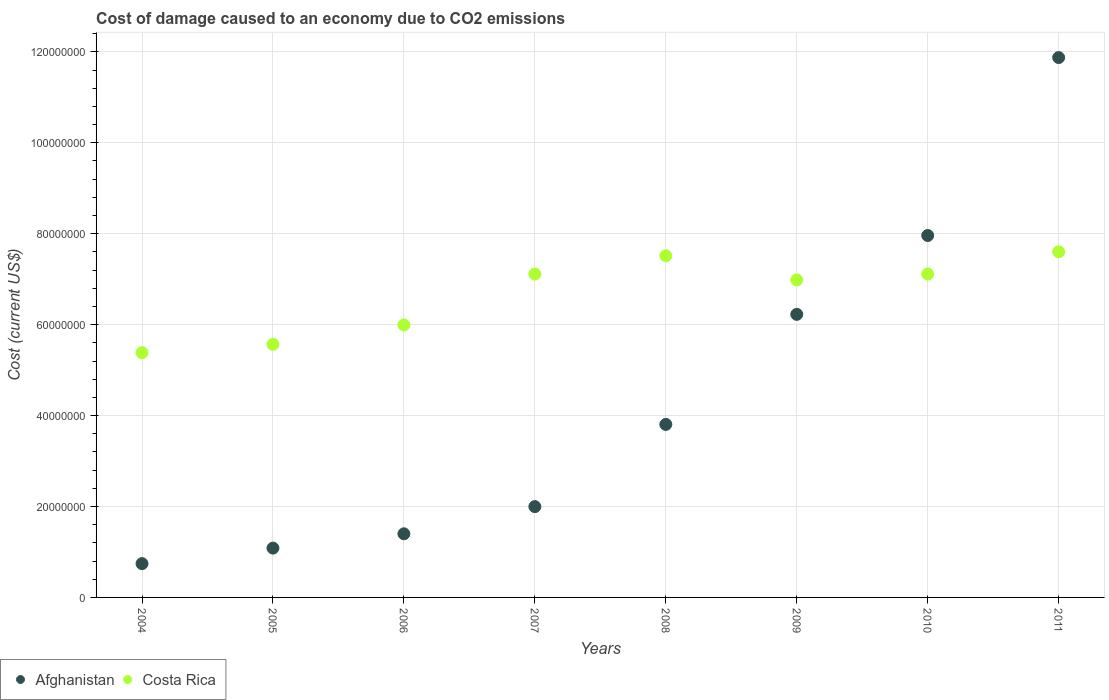How many different coloured dotlines are there?
Ensure brevity in your answer.  2. What is the cost of damage caused due to CO2 emissisons in Costa Rica in 2010?
Offer a terse response. 7.11e+07. Across all years, what is the maximum cost of damage caused due to CO2 emissisons in Afghanistan?
Provide a short and direct response. 1.19e+08. Across all years, what is the minimum cost of damage caused due to CO2 emissisons in Afghanistan?
Offer a terse response. 7.43e+06. In which year was the cost of damage caused due to CO2 emissisons in Costa Rica minimum?
Ensure brevity in your answer.  2004. What is the total cost of damage caused due to CO2 emissisons in Costa Rica in the graph?
Make the answer very short. 5.33e+08. What is the difference between the cost of damage caused due to CO2 emissisons in Costa Rica in 2004 and that in 2008?
Make the answer very short. -2.13e+07. What is the difference between the cost of damage caused due to CO2 emissisons in Costa Rica in 2011 and the cost of damage caused due to CO2 emissisons in Afghanistan in 2009?
Provide a succinct answer. 1.38e+07. What is the average cost of damage caused due to CO2 emissisons in Afghanistan per year?
Keep it short and to the point. 4.39e+07. In the year 2010, what is the difference between the cost of damage caused due to CO2 emissisons in Afghanistan and cost of damage caused due to CO2 emissisons in Costa Rica?
Your answer should be compact. 8.48e+06. In how many years, is the cost of damage caused due to CO2 emissisons in Costa Rica greater than 44000000 US$?
Provide a succinct answer. 8. What is the ratio of the cost of damage caused due to CO2 emissisons in Afghanistan in 2004 to that in 2005?
Offer a very short reply. 0.69. What is the difference between the highest and the second highest cost of damage caused due to CO2 emissisons in Afghanistan?
Keep it short and to the point. 3.91e+07. What is the difference between the highest and the lowest cost of damage caused due to CO2 emissisons in Costa Rica?
Your response must be concise. 2.22e+07. In how many years, is the cost of damage caused due to CO2 emissisons in Afghanistan greater than the average cost of damage caused due to CO2 emissisons in Afghanistan taken over all years?
Your answer should be very brief. 3. Is the sum of the cost of damage caused due to CO2 emissisons in Afghanistan in 2010 and 2011 greater than the maximum cost of damage caused due to CO2 emissisons in Costa Rica across all years?
Offer a terse response. Yes. Does the cost of damage caused due to CO2 emissisons in Afghanistan monotonically increase over the years?
Keep it short and to the point. Yes. How many dotlines are there?
Ensure brevity in your answer.  2. Are the values on the major ticks of Y-axis written in scientific E-notation?
Offer a terse response. No. Does the graph contain any zero values?
Offer a very short reply. No. Does the graph contain grids?
Make the answer very short. Yes. Where does the legend appear in the graph?
Provide a short and direct response. Bottom left. How many legend labels are there?
Offer a very short reply. 2. What is the title of the graph?
Offer a terse response. Cost of damage caused to an economy due to CO2 emissions. What is the label or title of the Y-axis?
Keep it short and to the point. Cost (current US$). What is the Cost (current US$) in Afghanistan in 2004?
Your response must be concise. 7.43e+06. What is the Cost (current US$) of Costa Rica in 2004?
Provide a succinct answer. 5.38e+07. What is the Cost (current US$) of Afghanistan in 2005?
Provide a short and direct response. 1.08e+07. What is the Cost (current US$) of Costa Rica in 2005?
Ensure brevity in your answer.  5.57e+07. What is the Cost (current US$) in Afghanistan in 2006?
Ensure brevity in your answer.  1.40e+07. What is the Cost (current US$) of Costa Rica in 2006?
Offer a terse response. 5.99e+07. What is the Cost (current US$) in Afghanistan in 2007?
Your answer should be compact. 2.00e+07. What is the Cost (current US$) of Costa Rica in 2007?
Provide a succinct answer. 7.11e+07. What is the Cost (current US$) in Afghanistan in 2008?
Provide a short and direct response. 3.81e+07. What is the Cost (current US$) of Costa Rica in 2008?
Your response must be concise. 7.51e+07. What is the Cost (current US$) of Afghanistan in 2009?
Your response must be concise. 6.23e+07. What is the Cost (current US$) in Costa Rica in 2009?
Your answer should be compact. 6.98e+07. What is the Cost (current US$) of Afghanistan in 2010?
Give a very brief answer. 7.96e+07. What is the Cost (current US$) in Costa Rica in 2010?
Provide a short and direct response. 7.11e+07. What is the Cost (current US$) of Afghanistan in 2011?
Give a very brief answer. 1.19e+08. What is the Cost (current US$) of Costa Rica in 2011?
Your response must be concise. 7.60e+07. Across all years, what is the maximum Cost (current US$) in Afghanistan?
Provide a succinct answer. 1.19e+08. Across all years, what is the maximum Cost (current US$) of Costa Rica?
Your response must be concise. 7.60e+07. Across all years, what is the minimum Cost (current US$) of Afghanistan?
Offer a very short reply. 7.43e+06. Across all years, what is the minimum Cost (current US$) of Costa Rica?
Ensure brevity in your answer.  5.38e+07. What is the total Cost (current US$) of Afghanistan in the graph?
Offer a very short reply. 3.51e+08. What is the total Cost (current US$) of Costa Rica in the graph?
Make the answer very short. 5.33e+08. What is the difference between the Cost (current US$) of Afghanistan in 2004 and that in 2005?
Offer a terse response. -3.42e+06. What is the difference between the Cost (current US$) of Costa Rica in 2004 and that in 2005?
Offer a terse response. -1.84e+06. What is the difference between the Cost (current US$) in Afghanistan in 2004 and that in 2006?
Your response must be concise. -6.56e+06. What is the difference between the Cost (current US$) in Costa Rica in 2004 and that in 2006?
Provide a short and direct response. -6.11e+06. What is the difference between the Cost (current US$) of Afghanistan in 2004 and that in 2007?
Give a very brief answer. -1.25e+07. What is the difference between the Cost (current US$) in Costa Rica in 2004 and that in 2007?
Make the answer very short. -1.73e+07. What is the difference between the Cost (current US$) of Afghanistan in 2004 and that in 2008?
Make the answer very short. -3.06e+07. What is the difference between the Cost (current US$) of Costa Rica in 2004 and that in 2008?
Your answer should be very brief. -2.13e+07. What is the difference between the Cost (current US$) of Afghanistan in 2004 and that in 2009?
Provide a short and direct response. -5.48e+07. What is the difference between the Cost (current US$) in Costa Rica in 2004 and that in 2009?
Give a very brief answer. -1.60e+07. What is the difference between the Cost (current US$) in Afghanistan in 2004 and that in 2010?
Provide a short and direct response. -7.22e+07. What is the difference between the Cost (current US$) in Costa Rica in 2004 and that in 2010?
Give a very brief answer. -1.73e+07. What is the difference between the Cost (current US$) in Afghanistan in 2004 and that in 2011?
Your response must be concise. -1.11e+08. What is the difference between the Cost (current US$) of Costa Rica in 2004 and that in 2011?
Provide a succinct answer. -2.22e+07. What is the difference between the Cost (current US$) in Afghanistan in 2005 and that in 2006?
Keep it short and to the point. -3.14e+06. What is the difference between the Cost (current US$) in Costa Rica in 2005 and that in 2006?
Provide a succinct answer. -4.26e+06. What is the difference between the Cost (current US$) in Afghanistan in 2005 and that in 2007?
Offer a very short reply. -9.13e+06. What is the difference between the Cost (current US$) in Costa Rica in 2005 and that in 2007?
Ensure brevity in your answer.  -1.55e+07. What is the difference between the Cost (current US$) in Afghanistan in 2005 and that in 2008?
Your answer should be very brief. -2.72e+07. What is the difference between the Cost (current US$) in Costa Rica in 2005 and that in 2008?
Offer a very short reply. -1.95e+07. What is the difference between the Cost (current US$) in Afghanistan in 2005 and that in 2009?
Give a very brief answer. -5.14e+07. What is the difference between the Cost (current US$) in Costa Rica in 2005 and that in 2009?
Make the answer very short. -1.42e+07. What is the difference between the Cost (current US$) of Afghanistan in 2005 and that in 2010?
Your response must be concise. -6.88e+07. What is the difference between the Cost (current US$) in Costa Rica in 2005 and that in 2010?
Keep it short and to the point. -1.55e+07. What is the difference between the Cost (current US$) of Afghanistan in 2005 and that in 2011?
Provide a succinct answer. -1.08e+08. What is the difference between the Cost (current US$) of Costa Rica in 2005 and that in 2011?
Provide a succinct answer. -2.04e+07. What is the difference between the Cost (current US$) of Afghanistan in 2006 and that in 2007?
Give a very brief answer. -5.98e+06. What is the difference between the Cost (current US$) in Costa Rica in 2006 and that in 2007?
Give a very brief answer. -1.12e+07. What is the difference between the Cost (current US$) of Afghanistan in 2006 and that in 2008?
Your response must be concise. -2.41e+07. What is the difference between the Cost (current US$) in Costa Rica in 2006 and that in 2008?
Keep it short and to the point. -1.52e+07. What is the difference between the Cost (current US$) in Afghanistan in 2006 and that in 2009?
Provide a succinct answer. -4.83e+07. What is the difference between the Cost (current US$) in Costa Rica in 2006 and that in 2009?
Keep it short and to the point. -9.91e+06. What is the difference between the Cost (current US$) in Afghanistan in 2006 and that in 2010?
Provide a succinct answer. -6.56e+07. What is the difference between the Cost (current US$) of Costa Rica in 2006 and that in 2010?
Give a very brief answer. -1.12e+07. What is the difference between the Cost (current US$) in Afghanistan in 2006 and that in 2011?
Make the answer very short. -1.05e+08. What is the difference between the Cost (current US$) in Costa Rica in 2006 and that in 2011?
Provide a succinct answer. -1.61e+07. What is the difference between the Cost (current US$) in Afghanistan in 2007 and that in 2008?
Your answer should be very brief. -1.81e+07. What is the difference between the Cost (current US$) of Costa Rica in 2007 and that in 2008?
Your response must be concise. -4.01e+06. What is the difference between the Cost (current US$) in Afghanistan in 2007 and that in 2009?
Give a very brief answer. -4.23e+07. What is the difference between the Cost (current US$) in Costa Rica in 2007 and that in 2009?
Make the answer very short. 1.29e+06. What is the difference between the Cost (current US$) of Afghanistan in 2007 and that in 2010?
Your answer should be compact. -5.96e+07. What is the difference between the Cost (current US$) in Costa Rica in 2007 and that in 2010?
Keep it short and to the point. 6889.78. What is the difference between the Cost (current US$) of Afghanistan in 2007 and that in 2011?
Provide a succinct answer. -9.88e+07. What is the difference between the Cost (current US$) in Costa Rica in 2007 and that in 2011?
Provide a succinct answer. -4.89e+06. What is the difference between the Cost (current US$) in Afghanistan in 2008 and that in 2009?
Provide a short and direct response. -2.42e+07. What is the difference between the Cost (current US$) of Costa Rica in 2008 and that in 2009?
Provide a succinct answer. 5.30e+06. What is the difference between the Cost (current US$) of Afghanistan in 2008 and that in 2010?
Provide a short and direct response. -4.16e+07. What is the difference between the Cost (current US$) of Costa Rica in 2008 and that in 2010?
Your answer should be very brief. 4.02e+06. What is the difference between the Cost (current US$) in Afghanistan in 2008 and that in 2011?
Your answer should be compact. -8.07e+07. What is the difference between the Cost (current US$) of Costa Rica in 2008 and that in 2011?
Your response must be concise. -8.80e+05. What is the difference between the Cost (current US$) in Afghanistan in 2009 and that in 2010?
Provide a succinct answer. -1.73e+07. What is the difference between the Cost (current US$) in Costa Rica in 2009 and that in 2010?
Keep it short and to the point. -1.29e+06. What is the difference between the Cost (current US$) in Afghanistan in 2009 and that in 2011?
Offer a very short reply. -5.65e+07. What is the difference between the Cost (current US$) in Costa Rica in 2009 and that in 2011?
Make the answer very short. -6.18e+06. What is the difference between the Cost (current US$) in Afghanistan in 2010 and that in 2011?
Provide a succinct answer. -3.91e+07. What is the difference between the Cost (current US$) of Costa Rica in 2010 and that in 2011?
Give a very brief answer. -4.90e+06. What is the difference between the Cost (current US$) in Afghanistan in 2004 and the Cost (current US$) in Costa Rica in 2005?
Your answer should be very brief. -4.82e+07. What is the difference between the Cost (current US$) of Afghanistan in 2004 and the Cost (current US$) of Costa Rica in 2006?
Offer a very short reply. -5.25e+07. What is the difference between the Cost (current US$) of Afghanistan in 2004 and the Cost (current US$) of Costa Rica in 2007?
Your answer should be very brief. -6.37e+07. What is the difference between the Cost (current US$) in Afghanistan in 2004 and the Cost (current US$) in Costa Rica in 2008?
Your answer should be compact. -6.77e+07. What is the difference between the Cost (current US$) in Afghanistan in 2004 and the Cost (current US$) in Costa Rica in 2009?
Make the answer very short. -6.24e+07. What is the difference between the Cost (current US$) of Afghanistan in 2004 and the Cost (current US$) of Costa Rica in 2010?
Provide a succinct answer. -6.37e+07. What is the difference between the Cost (current US$) of Afghanistan in 2004 and the Cost (current US$) of Costa Rica in 2011?
Keep it short and to the point. -6.86e+07. What is the difference between the Cost (current US$) of Afghanistan in 2005 and the Cost (current US$) of Costa Rica in 2006?
Give a very brief answer. -4.91e+07. What is the difference between the Cost (current US$) in Afghanistan in 2005 and the Cost (current US$) in Costa Rica in 2007?
Offer a very short reply. -6.03e+07. What is the difference between the Cost (current US$) in Afghanistan in 2005 and the Cost (current US$) in Costa Rica in 2008?
Ensure brevity in your answer.  -6.43e+07. What is the difference between the Cost (current US$) in Afghanistan in 2005 and the Cost (current US$) in Costa Rica in 2009?
Provide a succinct answer. -5.90e+07. What is the difference between the Cost (current US$) of Afghanistan in 2005 and the Cost (current US$) of Costa Rica in 2010?
Your answer should be very brief. -6.03e+07. What is the difference between the Cost (current US$) in Afghanistan in 2005 and the Cost (current US$) in Costa Rica in 2011?
Provide a short and direct response. -6.52e+07. What is the difference between the Cost (current US$) in Afghanistan in 2006 and the Cost (current US$) in Costa Rica in 2007?
Provide a short and direct response. -5.71e+07. What is the difference between the Cost (current US$) of Afghanistan in 2006 and the Cost (current US$) of Costa Rica in 2008?
Your answer should be very brief. -6.12e+07. What is the difference between the Cost (current US$) of Afghanistan in 2006 and the Cost (current US$) of Costa Rica in 2009?
Keep it short and to the point. -5.59e+07. What is the difference between the Cost (current US$) in Afghanistan in 2006 and the Cost (current US$) in Costa Rica in 2010?
Give a very brief answer. -5.71e+07. What is the difference between the Cost (current US$) in Afghanistan in 2006 and the Cost (current US$) in Costa Rica in 2011?
Provide a succinct answer. -6.20e+07. What is the difference between the Cost (current US$) in Afghanistan in 2007 and the Cost (current US$) in Costa Rica in 2008?
Ensure brevity in your answer.  -5.52e+07. What is the difference between the Cost (current US$) in Afghanistan in 2007 and the Cost (current US$) in Costa Rica in 2009?
Provide a succinct answer. -4.99e+07. What is the difference between the Cost (current US$) of Afghanistan in 2007 and the Cost (current US$) of Costa Rica in 2010?
Offer a terse response. -5.12e+07. What is the difference between the Cost (current US$) in Afghanistan in 2007 and the Cost (current US$) in Costa Rica in 2011?
Your answer should be compact. -5.61e+07. What is the difference between the Cost (current US$) of Afghanistan in 2008 and the Cost (current US$) of Costa Rica in 2009?
Provide a short and direct response. -3.18e+07. What is the difference between the Cost (current US$) in Afghanistan in 2008 and the Cost (current US$) in Costa Rica in 2010?
Your answer should be very brief. -3.31e+07. What is the difference between the Cost (current US$) in Afghanistan in 2008 and the Cost (current US$) in Costa Rica in 2011?
Provide a short and direct response. -3.80e+07. What is the difference between the Cost (current US$) in Afghanistan in 2009 and the Cost (current US$) in Costa Rica in 2010?
Provide a succinct answer. -8.87e+06. What is the difference between the Cost (current US$) of Afghanistan in 2009 and the Cost (current US$) of Costa Rica in 2011?
Offer a terse response. -1.38e+07. What is the difference between the Cost (current US$) of Afghanistan in 2010 and the Cost (current US$) of Costa Rica in 2011?
Provide a short and direct response. 3.58e+06. What is the average Cost (current US$) in Afghanistan per year?
Offer a terse response. 4.39e+07. What is the average Cost (current US$) of Costa Rica per year?
Your answer should be very brief. 6.66e+07. In the year 2004, what is the difference between the Cost (current US$) of Afghanistan and Cost (current US$) of Costa Rica?
Make the answer very short. -4.64e+07. In the year 2005, what is the difference between the Cost (current US$) in Afghanistan and Cost (current US$) in Costa Rica?
Give a very brief answer. -4.48e+07. In the year 2006, what is the difference between the Cost (current US$) in Afghanistan and Cost (current US$) in Costa Rica?
Ensure brevity in your answer.  -4.59e+07. In the year 2007, what is the difference between the Cost (current US$) in Afghanistan and Cost (current US$) in Costa Rica?
Make the answer very short. -5.12e+07. In the year 2008, what is the difference between the Cost (current US$) of Afghanistan and Cost (current US$) of Costa Rica?
Your response must be concise. -3.71e+07. In the year 2009, what is the difference between the Cost (current US$) of Afghanistan and Cost (current US$) of Costa Rica?
Offer a terse response. -7.58e+06. In the year 2010, what is the difference between the Cost (current US$) of Afghanistan and Cost (current US$) of Costa Rica?
Your response must be concise. 8.48e+06. In the year 2011, what is the difference between the Cost (current US$) in Afghanistan and Cost (current US$) in Costa Rica?
Ensure brevity in your answer.  4.27e+07. What is the ratio of the Cost (current US$) in Afghanistan in 2004 to that in 2005?
Your response must be concise. 0.69. What is the ratio of the Cost (current US$) of Costa Rica in 2004 to that in 2005?
Your response must be concise. 0.97. What is the ratio of the Cost (current US$) of Afghanistan in 2004 to that in 2006?
Your answer should be compact. 0.53. What is the ratio of the Cost (current US$) of Costa Rica in 2004 to that in 2006?
Provide a succinct answer. 0.9. What is the ratio of the Cost (current US$) in Afghanistan in 2004 to that in 2007?
Provide a short and direct response. 0.37. What is the ratio of the Cost (current US$) in Costa Rica in 2004 to that in 2007?
Your response must be concise. 0.76. What is the ratio of the Cost (current US$) in Afghanistan in 2004 to that in 2008?
Offer a terse response. 0.2. What is the ratio of the Cost (current US$) of Costa Rica in 2004 to that in 2008?
Provide a succinct answer. 0.72. What is the ratio of the Cost (current US$) in Afghanistan in 2004 to that in 2009?
Provide a short and direct response. 0.12. What is the ratio of the Cost (current US$) in Costa Rica in 2004 to that in 2009?
Your answer should be compact. 0.77. What is the ratio of the Cost (current US$) in Afghanistan in 2004 to that in 2010?
Your answer should be very brief. 0.09. What is the ratio of the Cost (current US$) in Costa Rica in 2004 to that in 2010?
Give a very brief answer. 0.76. What is the ratio of the Cost (current US$) of Afghanistan in 2004 to that in 2011?
Offer a very short reply. 0.06. What is the ratio of the Cost (current US$) in Costa Rica in 2004 to that in 2011?
Provide a succinct answer. 0.71. What is the ratio of the Cost (current US$) in Afghanistan in 2005 to that in 2006?
Give a very brief answer. 0.78. What is the ratio of the Cost (current US$) of Costa Rica in 2005 to that in 2006?
Your response must be concise. 0.93. What is the ratio of the Cost (current US$) in Afghanistan in 2005 to that in 2007?
Ensure brevity in your answer.  0.54. What is the ratio of the Cost (current US$) in Costa Rica in 2005 to that in 2007?
Your answer should be very brief. 0.78. What is the ratio of the Cost (current US$) in Afghanistan in 2005 to that in 2008?
Offer a very short reply. 0.29. What is the ratio of the Cost (current US$) in Costa Rica in 2005 to that in 2008?
Your response must be concise. 0.74. What is the ratio of the Cost (current US$) of Afghanistan in 2005 to that in 2009?
Ensure brevity in your answer.  0.17. What is the ratio of the Cost (current US$) in Costa Rica in 2005 to that in 2009?
Offer a terse response. 0.8. What is the ratio of the Cost (current US$) of Afghanistan in 2005 to that in 2010?
Your answer should be compact. 0.14. What is the ratio of the Cost (current US$) in Costa Rica in 2005 to that in 2010?
Make the answer very short. 0.78. What is the ratio of the Cost (current US$) of Afghanistan in 2005 to that in 2011?
Ensure brevity in your answer.  0.09. What is the ratio of the Cost (current US$) in Costa Rica in 2005 to that in 2011?
Your response must be concise. 0.73. What is the ratio of the Cost (current US$) of Afghanistan in 2006 to that in 2007?
Keep it short and to the point. 0.7. What is the ratio of the Cost (current US$) in Costa Rica in 2006 to that in 2007?
Provide a succinct answer. 0.84. What is the ratio of the Cost (current US$) in Afghanistan in 2006 to that in 2008?
Provide a succinct answer. 0.37. What is the ratio of the Cost (current US$) in Costa Rica in 2006 to that in 2008?
Offer a terse response. 0.8. What is the ratio of the Cost (current US$) in Afghanistan in 2006 to that in 2009?
Your answer should be compact. 0.22. What is the ratio of the Cost (current US$) of Costa Rica in 2006 to that in 2009?
Your answer should be compact. 0.86. What is the ratio of the Cost (current US$) of Afghanistan in 2006 to that in 2010?
Make the answer very short. 0.18. What is the ratio of the Cost (current US$) of Costa Rica in 2006 to that in 2010?
Your answer should be very brief. 0.84. What is the ratio of the Cost (current US$) of Afghanistan in 2006 to that in 2011?
Keep it short and to the point. 0.12. What is the ratio of the Cost (current US$) of Costa Rica in 2006 to that in 2011?
Make the answer very short. 0.79. What is the ratio of the Cost (current US$) of Afghanistan in 2007 to that in 2008?
Offer a very short reply. 0.52. What is the ratio of the Cost (current US$) of Costa Rica in 2007 to that in 2008?
Offer a very short reply. 0.95. What is the ratio of the Cost (current US$) in Afghanistan in 2007 to that in 2009?
Keep it short and to the point. 0.32. What is the ratio of the Cost (current US$) in Costa Rica in 2007 to that in 2009?
Provide a succinct answer. 1.02. What is the ratio of the Cost (current US$) of Afghanistan in 2007 to that in 2010?
Make the answer very short. 0.25. What is the ratio of the Cost (current US$) in Costa Rica in 2007 to that in 2010?
Your answer should be very brief. 1. What is the ratio of the Cost (current US$) of Afghanistan in 2007 to that in 2011?
Your response must be concise. 0.17. What is the ratio of the Cost (current US$) of Costa Rica in 2007 to that in 2011?
Make the answer very short. 0.94. What is the ratio of the Cost (current US$) in Afghanistan in 2008 to that in 2009?
Your answer should be compact. 0.61. What is the ratio of the Cost (current US$) of Costa Rica in 2008 to that in 2009?
Make the answer very short. 1.08. What is the ratio of the Cost (current US$) of Afghanistan in 2008 to that in 2010?
Ensure brevity in your answer.  0.48. What is the ratio of the Cost (current US$) of Costa Rica in 2008 to that in 2010?
Your answer should be compact. 1.06. What is the ratio of the Cost (current US$) in Afghanistan in 2008 to that in 2011?
Offer a terse response. 0.32. What is the ratio of the Cost (current US$) in Costa Rica in 2008 to that in 2011?
Keep it short and to the point. 0.99. What is the ratio of the Cost (current US$) of Afghanistan in 2009 to that in 2010?
Make the answer very short. 0.78. What is the ratio of the Cost (current US$) in Costa Rica in 2009 to that in 2010?
Offer a very short reply. 0.98. What is the ratio of the Cost (current US$) of Afghanistan in 2009 to that in 2011?
Give a very brief answer. 0.52. What is the ratio of the Cost (current US$) of Costa Rica in 2009 to that in 2011?
Your answer should be compact. 0.92. What is the ratio of the Cost (current US$) in Afghanistan in 2010 to that in 2011?
Your answer should be compact. 0.67. What is the ratio of the Cost (current US$) in Costa Rica in 2010 to that in 2011?
Provide a succinct answer. 0.94. What is the difference between the highest and the second highest Cost (current US$) in Afghanistan?
Provide a short and direct response. 3.91e+07. What is the difference between the highest and the second highest Cost (current US$) of Costa Rica?
Provide a succinct answer. 8.80e+05. What is the difference between the highest and the lowest Cost (current US$) in Afghanistan?
Make the answer very short. 1.11e+08. What is the difference between the highest and the lowest Cost (current US$) of Costa Rica?
Offer a very short reply. 2.22e+07. 